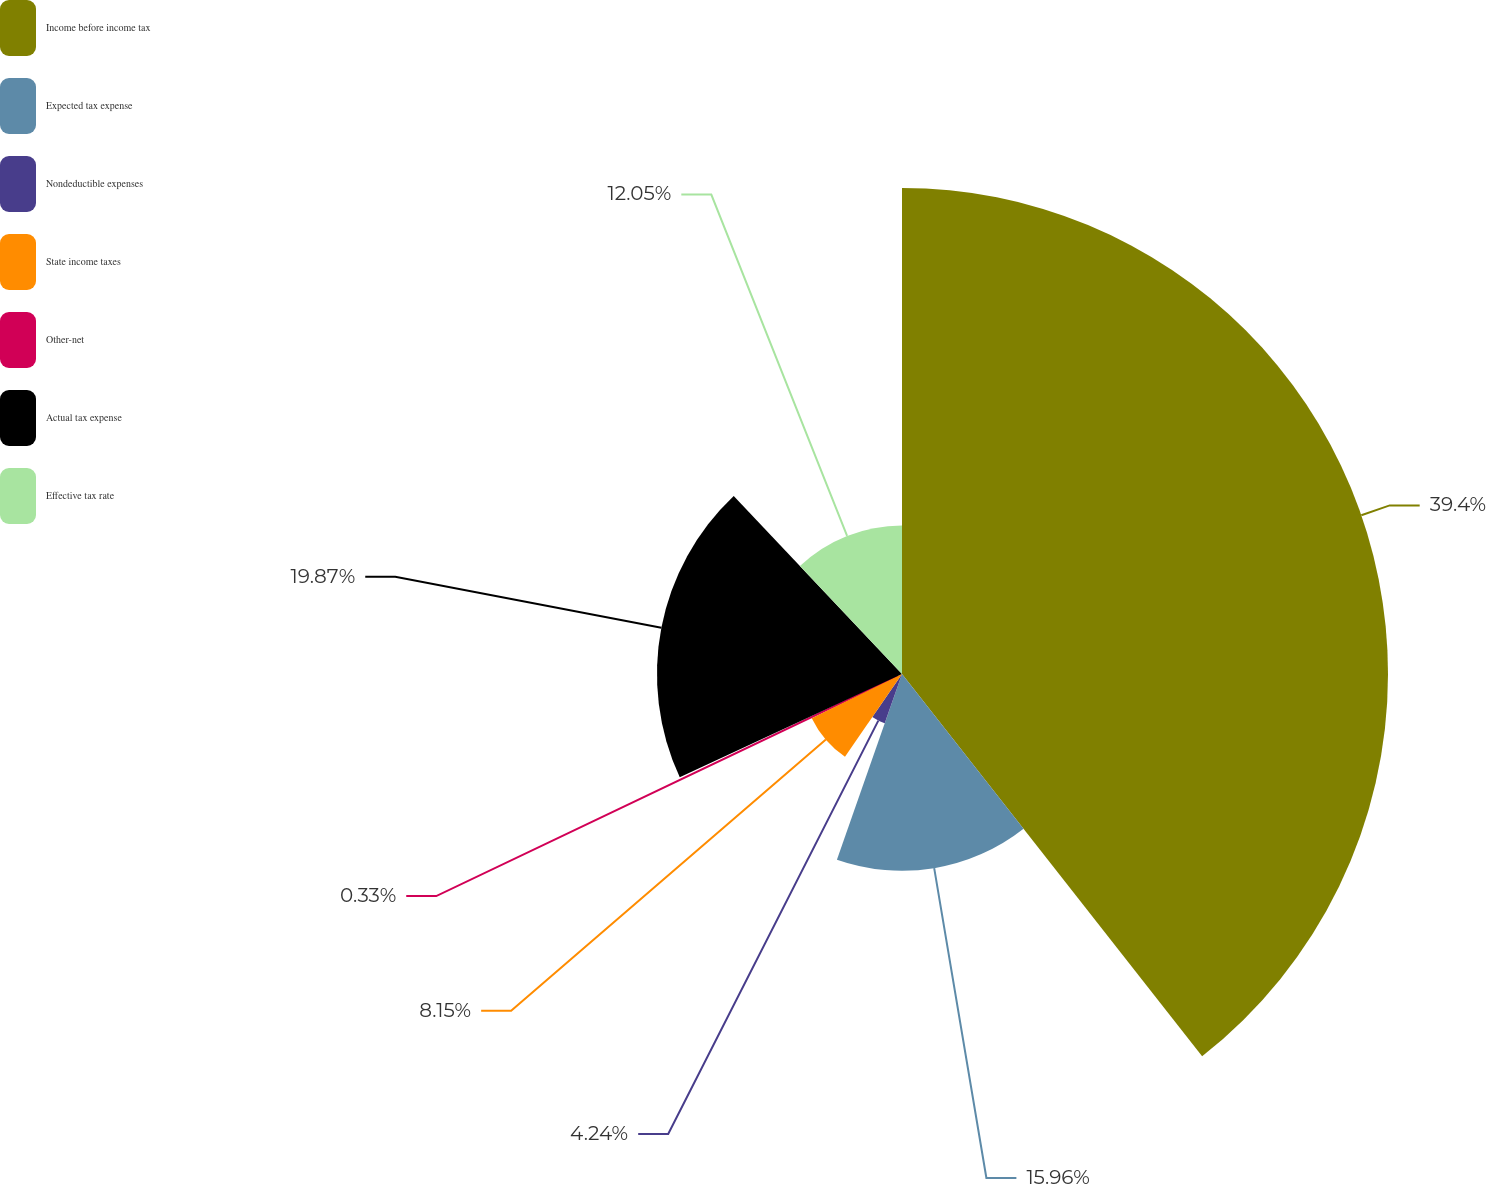Convert chart. <chart><loc_0><loc_0><loc_500><loc_500><pie_chart><fcel>Income before income tax<fcel>Expected tax expense<fcel>Nondeductible expenses<fcel>State income taxes<fcel>Other-net<fcel>Actual tax expense<fcel>Effective tax rate<nl><fcel>39.41%<fcel>15.96%<fcel>4.24%<fcel>8.15%<fcel>0.33%<fcel>19.87%<fcel>12.05%<nl></chart> 